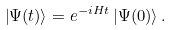Convert formula to latex. <formula><loc_0><loc_0><loc_500><loc_500>\left | \Psi ( t ) \right \rangle = e ^ { - i H t } \left | \Psi ( 0 ) \right \rangle .</formula> 